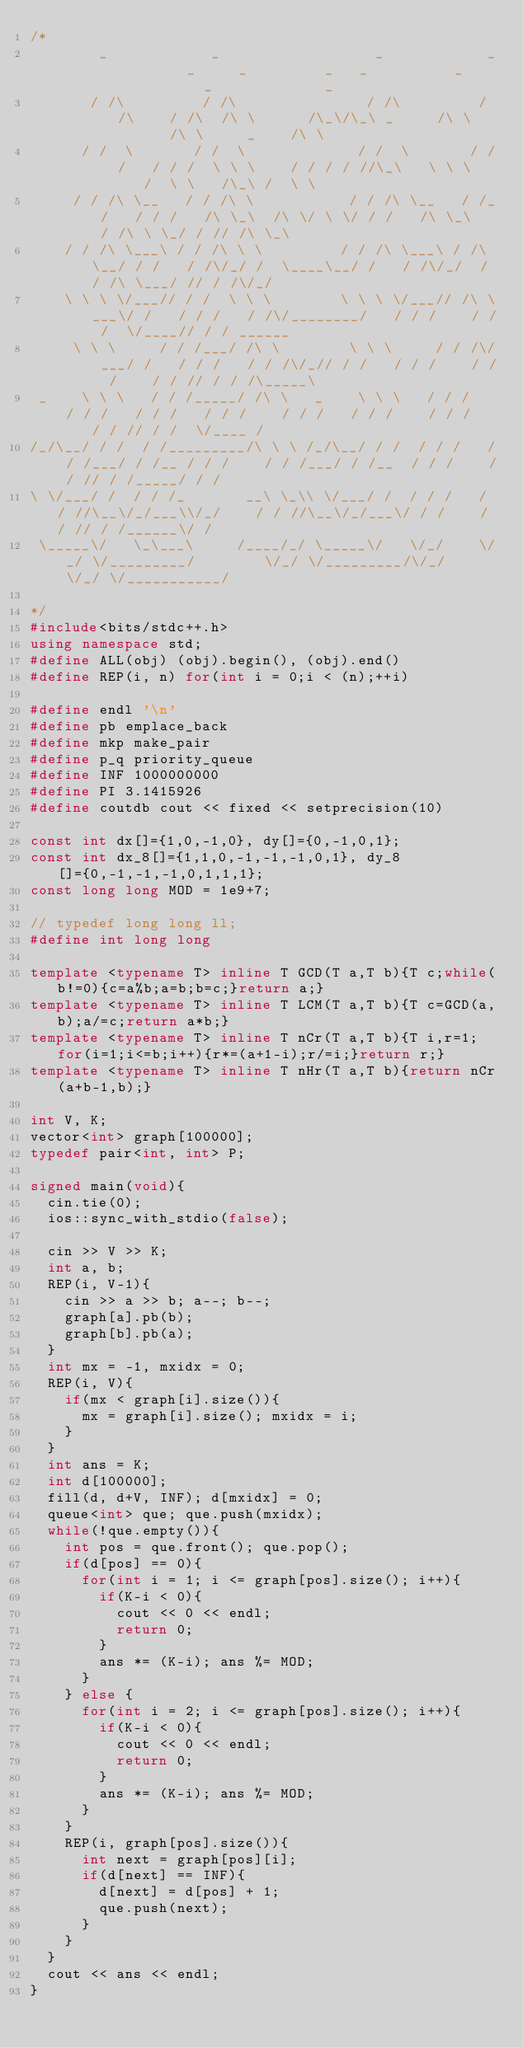<code> <loc_0><loc_0><loc_500><loc_500><_C++_>/*
        _            _                  _            _       _     _         _   _          _          _             _        
       / /\         / /\               / /\         / /\    / /\  /\ \      /\_\/\_\ _     /\ \       /\ \     _    /\ \      
      / /  \       / /  \             / /  \       / / /   / / /  \ \ \    / / / / //\_\   \ \ \     /  \ \   /\_\ /  \ \     
     / / /\ \__   / / /\ \           / / /\ \__   / /_/   / / /   /\ \_\  /\ \/ \ \/ / /   /\ \_\   / /\ \ \_/ / // /\ \_\    
    / / /\ \___\ / / /\ \ \         / / /\ \___\ / /\ \__/ / /   / /\/_/ /  \____\__/ /   / /\/_/  / / /\ \___/ // / /\/_/    
    \ \ \ \/___// / /  \ \ \        \ \ \ \/___// /\ \___\/ /   / / /   / /\/________/   / / /    / / /  \/____// / / ______  
     \ \ \     / / /___/ /\ \        \ \ \     / / /\/___/ /   / / /   / / /\/_// / /   / / /    / / /    / / // / / /\_____\ 
 _    \ \ \   / / /_____/ /\ \   _    \ \ \   / / /   / / /   / / /   / / /    / / /   / / /    / / /    / / // / /  \/____ / 
/_/\__/ / /  / /_________/\ \ \ /_/\__/ / /  / / /   / / /___/ / /__ / / /    / / /___/ / /__  / / /    / / // / /_____/ / /  
\ \/___/ /  / / /_       __\ \_\\ \/___/ /  / / /   / / //\__\/_/___\\/_/    / / //\__\/_/___\/ / /    / / // / /______\/ /   
 \_____\/   \_\___\     /____/_/ \_____\/   \/_/    \/_/ \/_________/        \/_/ \/_________/\/_/     \/_/ \/___________/    
                                                                                                                              
*/
#include<bits/stdc++.h>
using namespace std;
#define ALL(obj) (obj).begin(), (obj).end()
#define REP(i, n) for(int i = 0;i < (n);++i)

#define endl '\n'
#define pb emplace_back
#define mkp make_pair
#define p_q priority_queue
#define INF 1000000000
#define PI 3.1415926
#define coutdb cout << fixed << setprecision(10)

const int dx[]={1,0,-1,0}, dy[]={0,-1,0,1};
const int dx_8[]={1,1,0,-1,-1,-1,0,1}, dy_8[]={0,-1,-1,-1,0,1,1,1};
const long long MOD = 1e9+7;

// typedef long long ll;
#define int long long

template <typename T> inline T GCD(T a,T b){T c;while(b!=0){c=a%b;a=b;b=c;}return a;}
template <typename T> inline T LCM(T a,T b){T c=GCD(a,b);a/=c;return a*b;}
template <typename T> inline T nCr(T a,T b){T i,r=1;for(i=1;i<=b;i++){r*=(a+1-i);r/=i;}return r;}
template <typename T> inline T nHr(T a,T b){return nCr(a+b-1,b);}

int V, K;
vector<int> graph[100000];
typedef pair<int, int> P;

signed main(void){
  cin.tie(0);
  ios::sync_with_stdio(false);

  cin >> V >> K;
  int a, b;
  REP(i, V-1){
    cin >> a >> b; a--; b--;
    graph[a].pb(b);
    graph[b].pb(a);
  }
  int mx = -1, mxidx = 0;
  REP(i, V){
    if(mx < graph[i].size()){
      mx = graph[i].size(); mxidx = i;
    }
  }
  int ans = K;
  int d[100000];
  fill(d, d+V, INF); d[mxidx] = 0;
  queue<int> que; que.push(mxidx);
  while(!que.empty()){
    int pos = que.front(); que.pop();
    if(d[pos] == 0){
      for(int i = 1; i <= graph[pos].size(); i++){
        if(K-i < 0){
          cout << 0 << endl;
          return 0;
        }
        ans *= (K-i); ans %= MOD;
      }
    } else {
      for(int i = 2; i <= graph[pos].size(); i++){
        if(K-i < 0){
          cout << 0 << endl;
          return 0;
        }
        ans *= (K-i); ans %= MOD;
      }
    }
    REP(i, graph[pos].size()){
      int next = graph[pos][i];
      if(d[next] == INF){
        d[next] = d[pos] + 1;
        que.push(next);
      }
    }
  }
  cout << ans << endl;
}</code> 